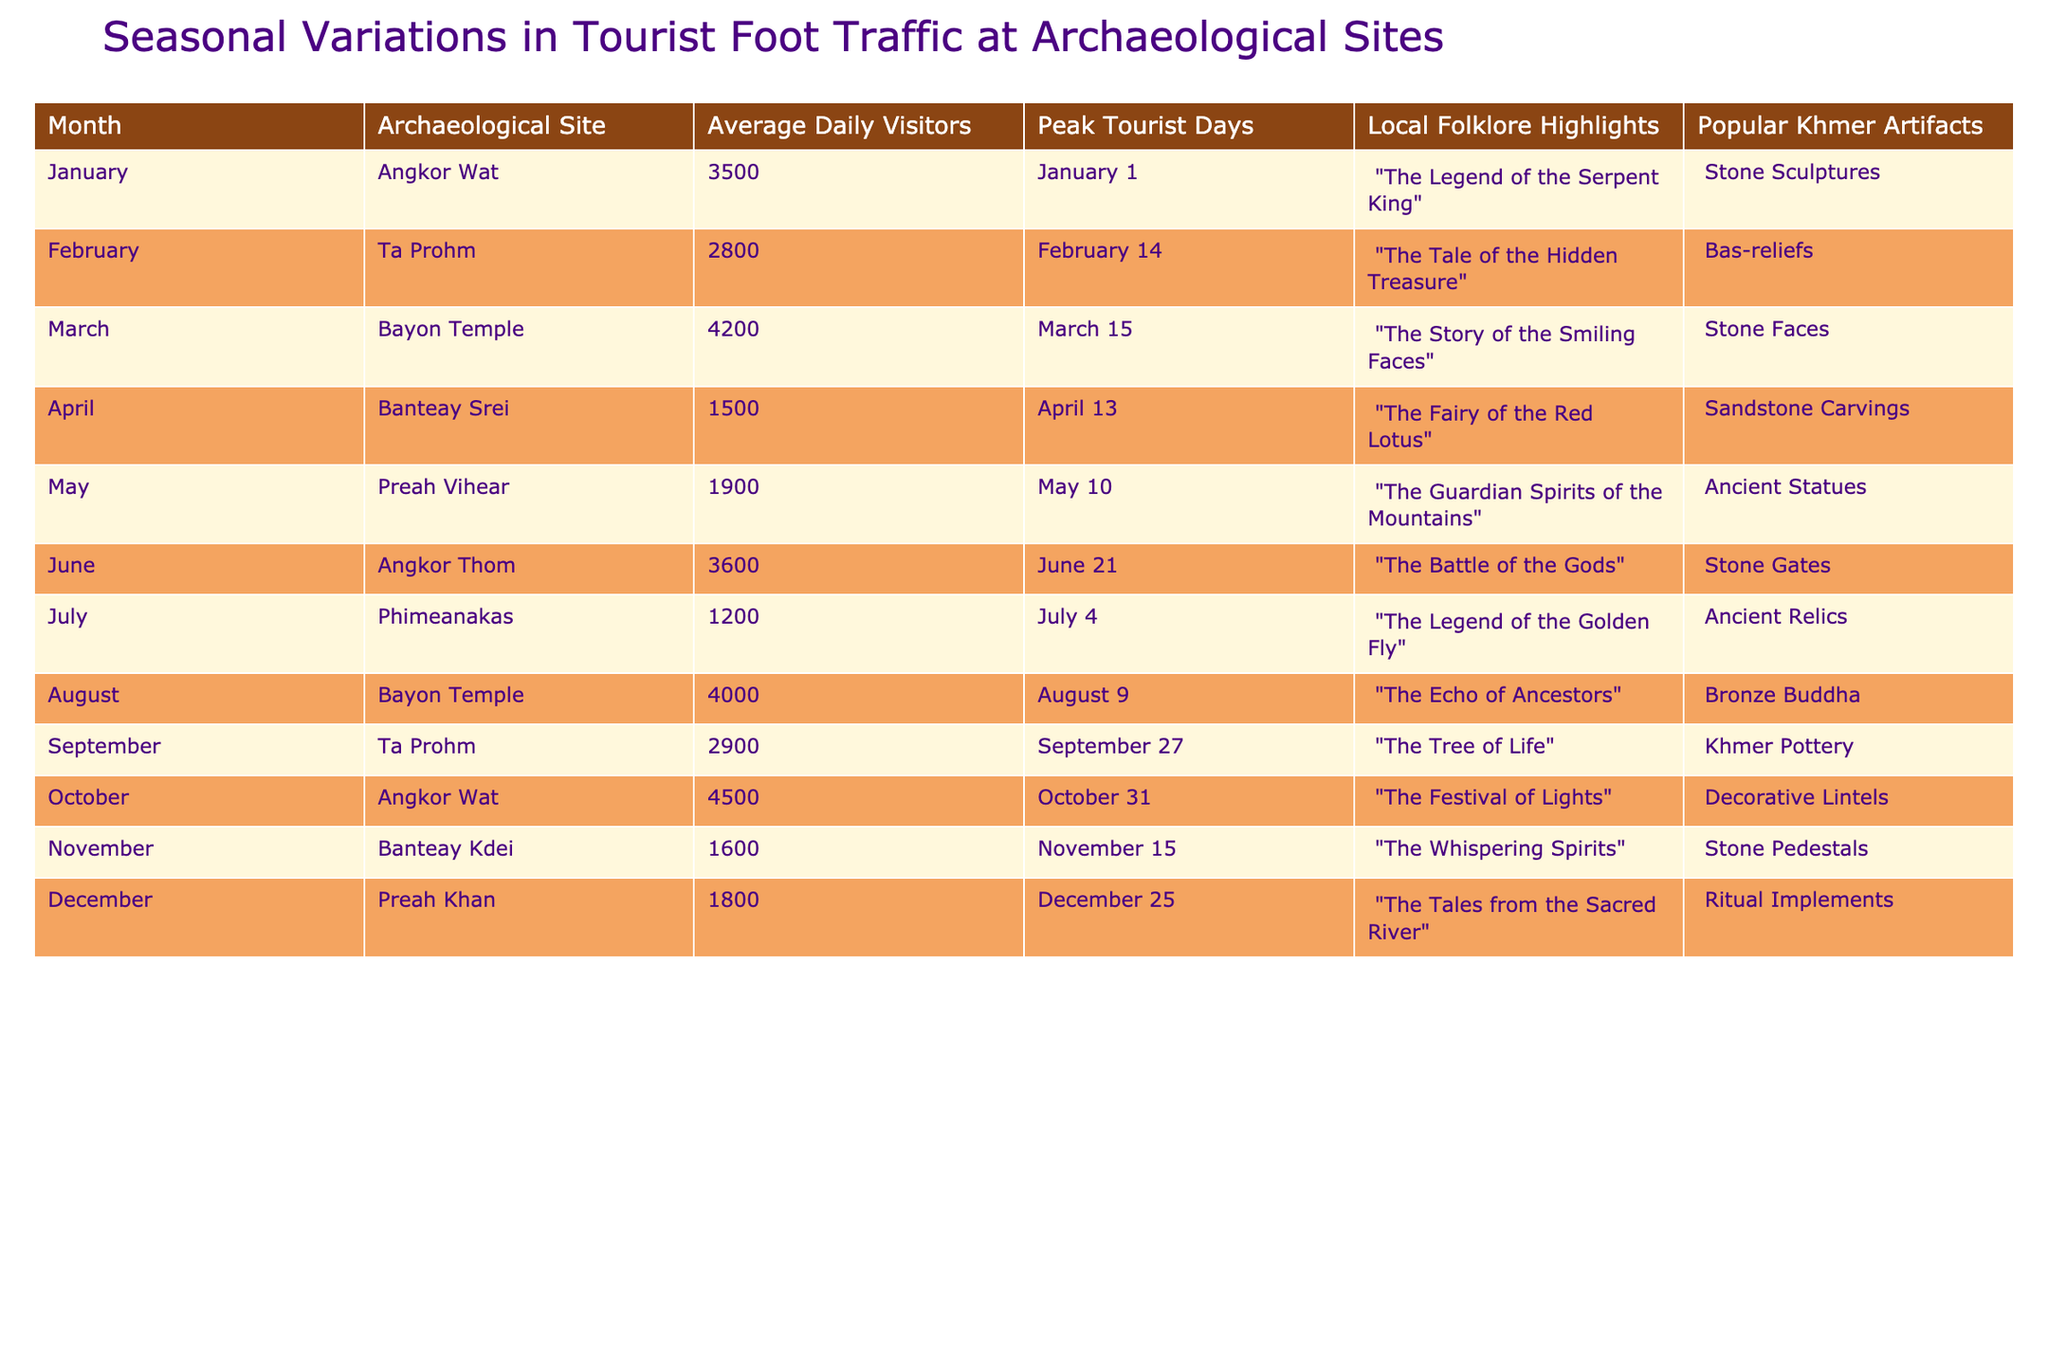What is the peak tourist day for Angkor Wat? According to the table, the peak tourist day for Angkor Wat is January 1.
Answer: January 1 Which archaeological site had the highest average daily visitors in October? The table shows that Angkor Wat had the highest average daily visitors in October at 4500.
Answer: Angkor Wat How many average daily visitors did Ta Prohm receive in February? The table indicates that Ta Prohm received 2800 average daily visitors in February.
Answer: 2800 Which site has the lowest average daily visitors in the summer months (June, July, August)? By examining the average daily visitors for June (3600), July (1200), and August (4000), it is clear that Phimeanakas had the lowest at 1200.
Answer: Phimeanakas What is the total average daily visitors for all archaeological sites in March and April? The average daily visitors for March is 4200 (Bayon Temple) and for April is 1500 (Banteay Srei). Adding these gives 4200 + 1500 = 5700.
Answer: 5700 Which month had the most peak tourist days listed in the table? The table indicates that each month has one peak tourist day, so no month has more than others; they all have one.
Answer: No month has more; all have one Are there any sites with average daily visitors above 4000? The table shows that Angkor Wat in October (4500) and Bayon Temple in March (4200) both have average daily visitors above 4000.
Answer: Yes, Angkor Wat and Bayon Temple What is the difference in average daily visitors between Banteay Srei and Banteay Kdei? According to the table, Banteay Srei has 1500 average daily visitors while Banteay Kdei has 1600. The difference is 1600 - 1500 = 100.
Answer: 100 Which local folklore highlight corresponds with the peak tourist day of June 21? The table indicates that the local folklore highlight for June 21 (Angkor Thom) is "The Battle of the Gods".
Answer: The Battle of the Gods If we consider the average daily visitors for December, what is the average for Preah Khan and Banteay Srei combined? Preah Khan has 1800 average daily visitors and Banteay Srei has 1500. Summing these gives 1800 + 1500 = 3300, and then dividing by 2 for the average results in 3300/2 = 1650.
Answer: 1650 